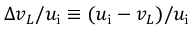Convert formula to latex. <formula><loc_0><loc_0><loc_500><loc_500>\Delta v _ { L } / u _ { i } \equiv ( u _ { i } - v _ { L } ) / u _ { i }</formula> 